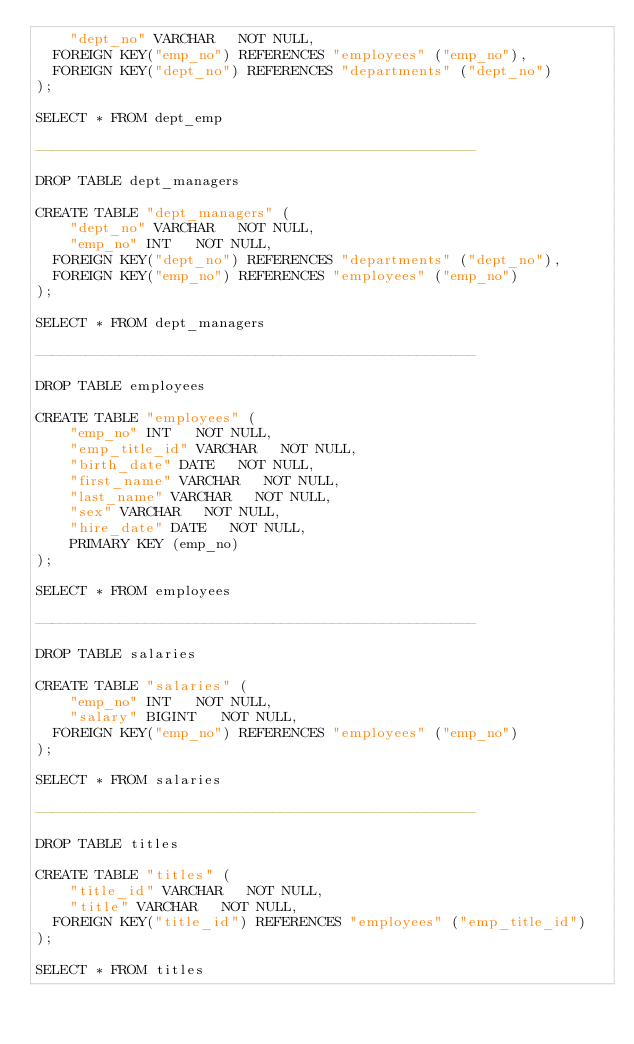<code> <loc_0><loc_0><loc_500><loc_500><_SQL_>    "dept_no" VARCHAR   NOT NULL,
	FOREIGN KEY("emp_no") REFERENCES "employees" ("emp_no"),
	FOREIGN KEY("dept_no") REFERENCES "departments" ("dept_no")
);

SELECT * FROM dept_emp

----------------------------------------------------

DROP TABLE dept_managers

CREATE TABLE "dept_managers" (
    "dept_no" VARCHAR   NOT NULL,
    "emp_no" INT   NOT NULL,
	FOREIGN KEY("dept_no") REFERENCES "departments" ("dept_no"),
	FOREIGN KEY("emp_no") REFERENCES "employees" ("emp_no")
);

SELECT * FROM dept_managers

----------------------------------------------------

DROP TABLE employees

CREATE TABLE "employees" (
    "emp_no" INT   NOT NULL,
    "emp_title_id" VARCHAR   NOT NULL,
    "birth_date" DATE   NOT NULL,
    "first_name" VARCHAR   NOT NULL,
    "last_name" VARCHAR   NOT NULL,
    "sex" VARCHAR   NOT NULL,
    "hire_date" DATE   NOT NULL,
    PRIMARY KEY (emp_no)
);

SELECT * FROM employees

----------------------------------------------------

DROP TABLE salaries

CREATE TABLE "salaries" (
    "emp_no" INT   NOT NULL,
    "salary" BIGINT   NOT NULL,
	FOREIGN KEY("emp_no") REFERENCES "employees" ("emp_no")
);

SELECT * FROM salaries

----------------------------------------------------

DROP TABLE titles

CREATE TABLE "titles" (
    "title_id" VARCHAR   NOT NULL,
    "title" VARCHAR   NOT NULL,
	FOREIGN KEY("title_id") REFERENCES "employees" ("emp_title_id")
);

SELECT * FROM titles


</code> 